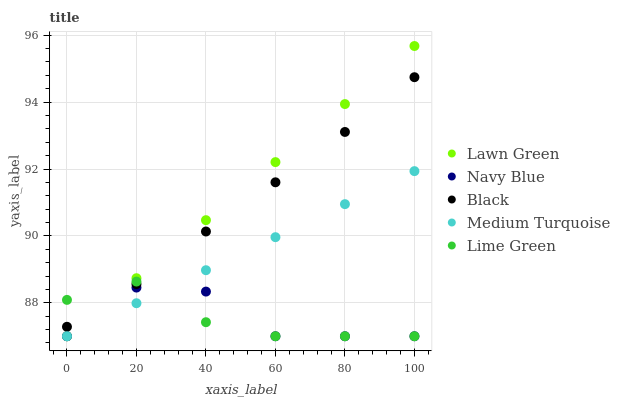Does Lime Green have the minimum area under the curve?
Answer yes or no. Yes. Does Lawn Green have the maximum area under the curve?
Answer yes or no. Yes. Does Black have the minimum area under the curve?
Answer yes or no. No. Does Black have the maximum area under the curve?
Answer yes or no. No. Is Lawn Green the smoothest?
Answer yes or no. Yes. Is Navy Blue the roughest?
Answer yes or no. Yes. Is Black the smoothest?
Answer yes or no. No. Is Black the roughest?
Answer yes or no. No. Does Lime Green have the lowest value?
Answer yes or no. Yes. Does Black have the lowest value?
Answer yes or no. No. Does Lawn Green have the highest value?
Answer yes or no. Yes. Does Black have the highest value?
Answer yes or no. No. Is Medium Turquoise less than Black?
Answer yes or no. Yes. Is Black greater than Medium Turquoise?
Answer yes or no. Yes. Does Lawn Green intersect Navy Blue?
Answer yes or no. Yes. Is Lawn Green less than Navy Blue?
Answer yes or no. No. Is Lawn Green greater than Navy Blue?
Answer yes or no. No. Does Medium Turquoise intersect Black?
Answer yes or no. No. 